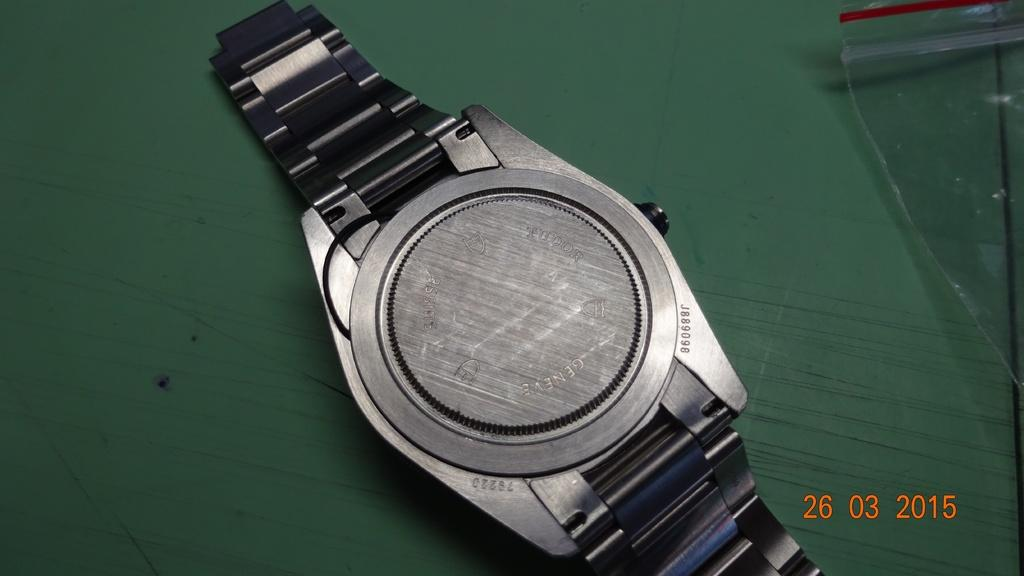<image>
Describe the image concisely. The back of a Geneve watch is shown in a photo from 2015. 